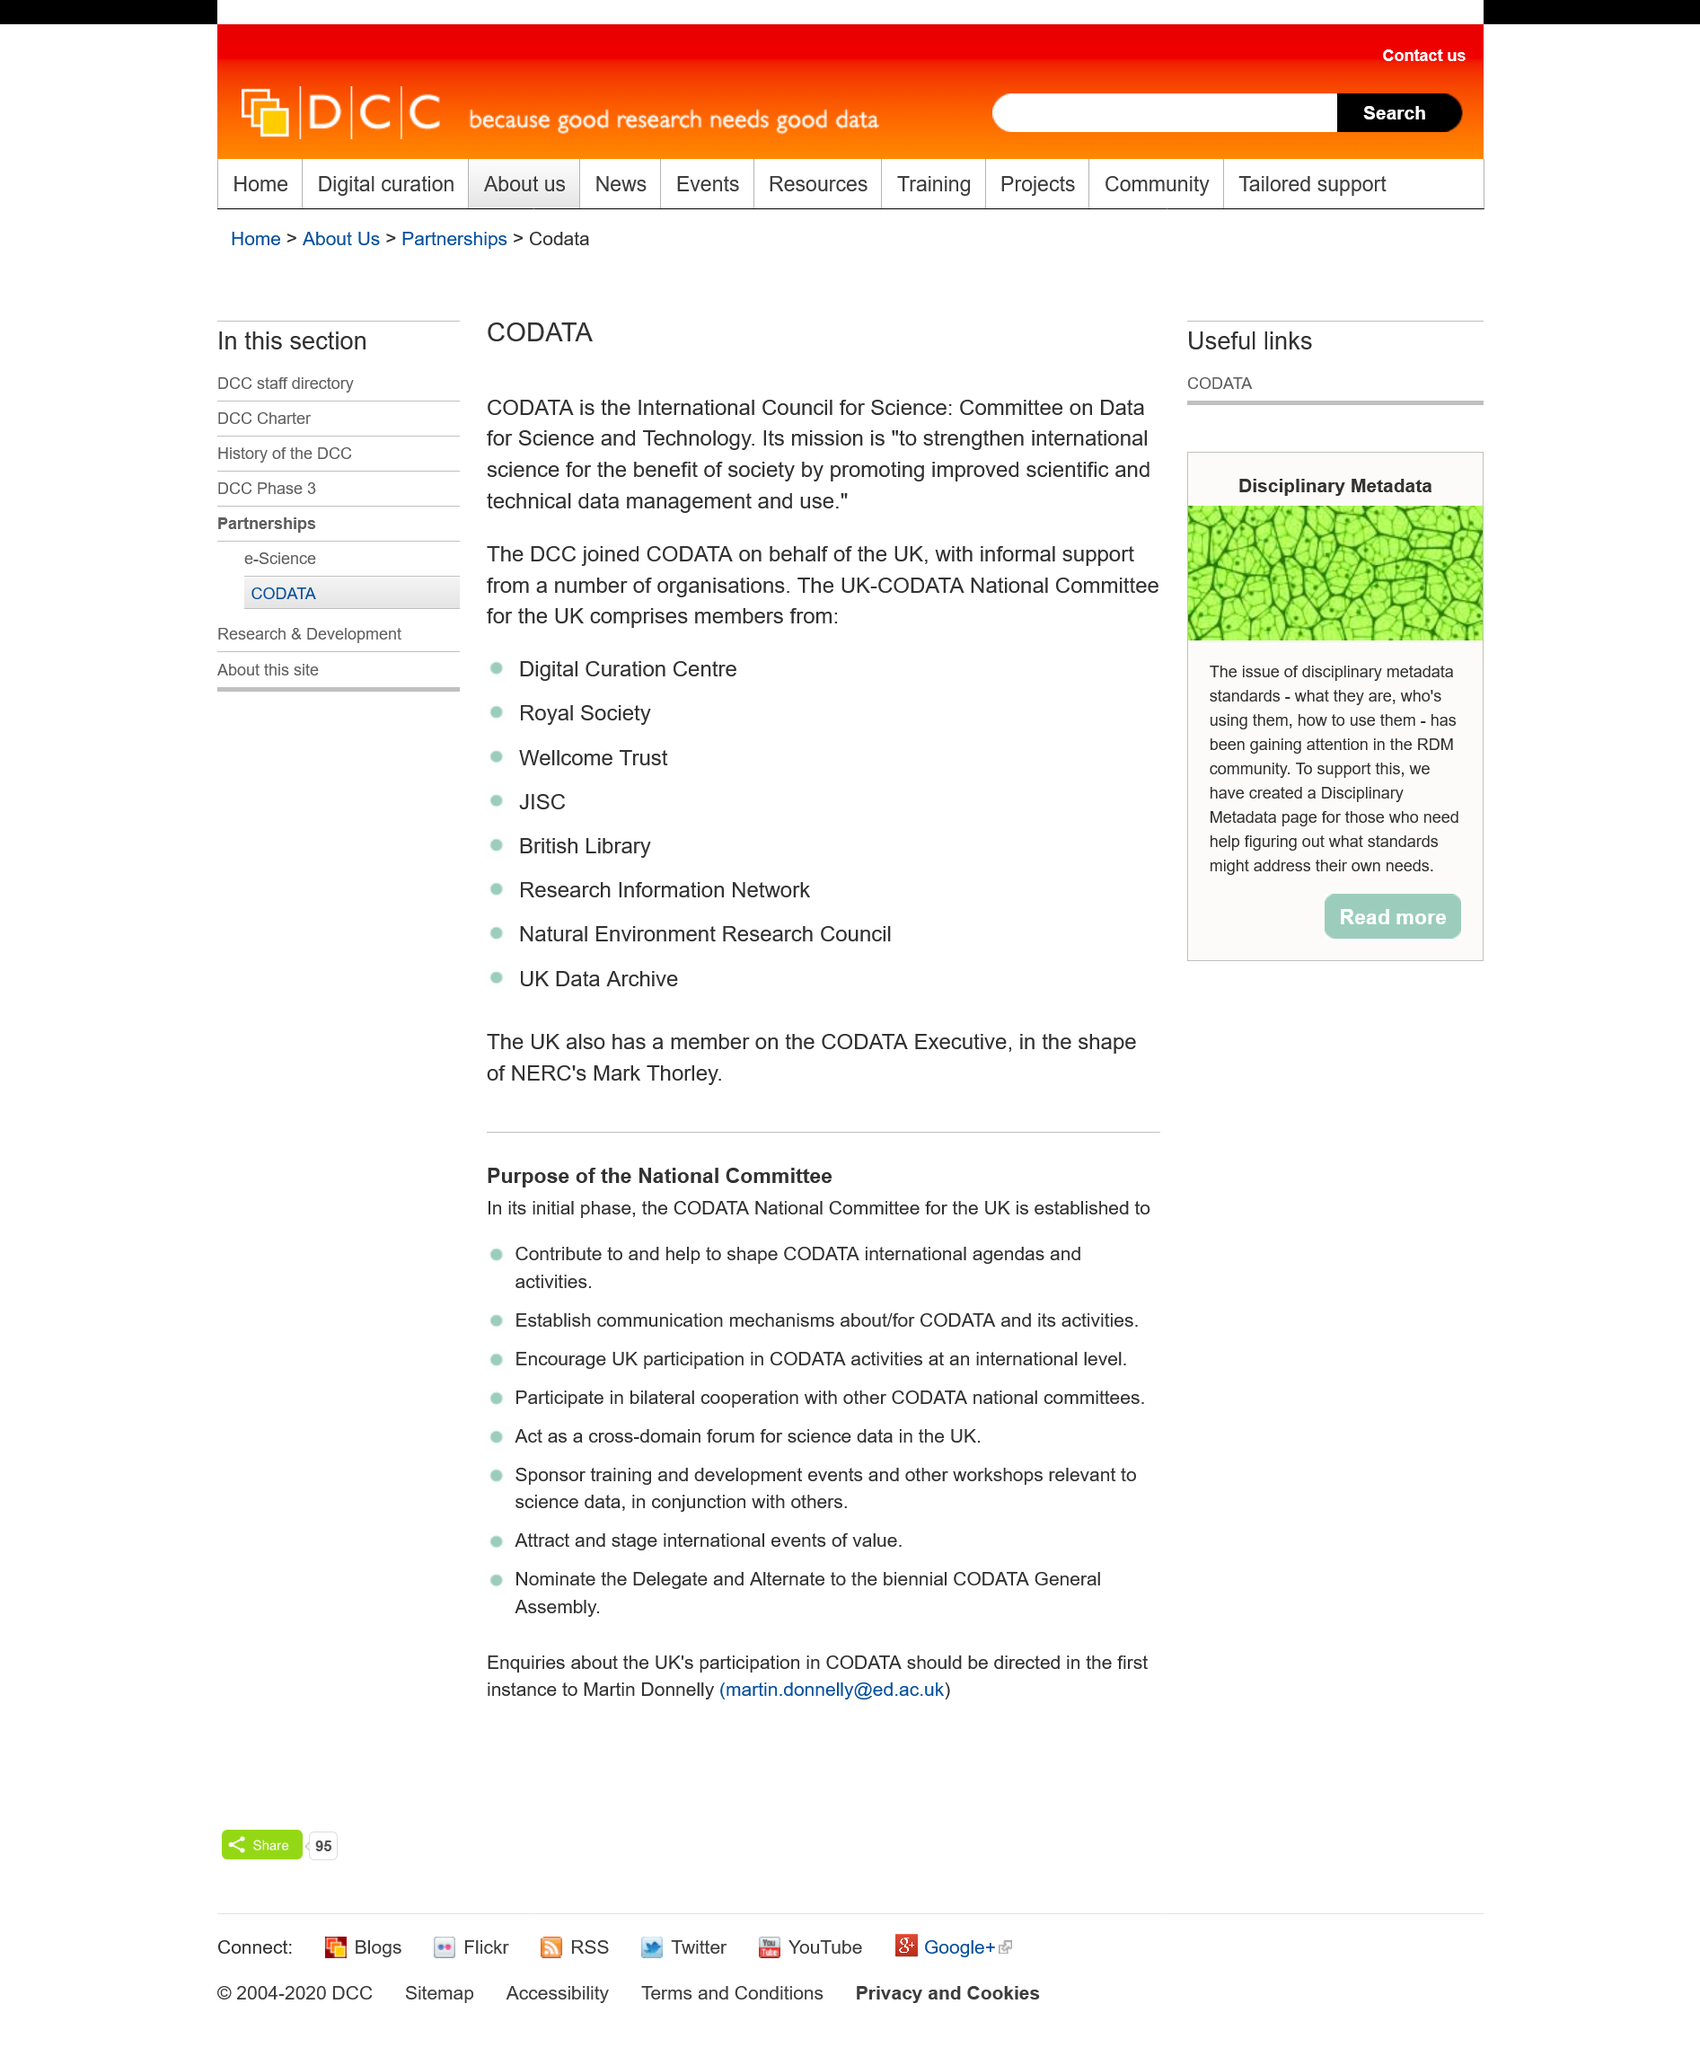Identify some key points in this picture. CODATA's mission is to improve scientific and technical data management and use, for the benefit of society and the advancement of science. The DCC joined CODATA on behalf of the UK. CODATA is a committee of the International Council for Science that focuses on providing data and technology for science and technology. 